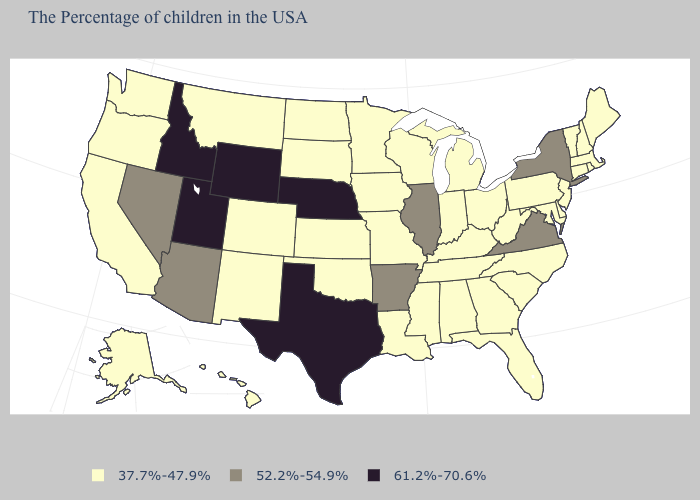Does the map have missing data?
Give a very brief answer. No. What is the lowest value in the USA?
Concise answer only. 37.7%-47.9%. Name the states that have a value in the range 61.2%-70.6%?
Concise answer only. Nebraska, Texas, Wyoming, Utah, Idaho. What is the value of Maine?
Short answer required. 37.7%-47.9%. Name the states that have a value in the range 52.2%-54.9%?
Concise answer only. New York, Virginia, Illinois, Arkansas, Arizona, Nevada. Name the states that have a value in the range 37.7%-47.9%?
Give a very brief answer. Maine, Massachusetts, Rhode Island, New Hampshire, Vermont, Connecticut, New Jersey, Delaware, Maryland, Pennsylvania, North Carolina, South Carolina, West Virginia, Ohio, Florida, Georgia, Michigan, Kentucky, Indiana, Alabama, Tennessee, Wisconsin, Mississippi, Louisiana, Missouri, Minnesota, Iowa, Kansas, Oklahoma, South Dakota, North Dakota, Colorado, New Mexico, Montana, California, Washington, Oregon, Alaska, Hawaii. Does Idaho have the highest value in the USA?
Give a very brief answer. Yes. Does New York have the lowest value in the Northeast?
Give a very brief answer. No. Name the states that have a value in the range 52.2%-54.9%?
Concise answer only. New York, Virginia, Illinois, Arkansas, Arizona, Nevada. What is the lowest value in states that border North Carolina?
Quick response, please. 37.7%-47.9%. Does Texas have the lowest value in the USA?
Answer briefly. No. What is the value of Idaho?
Answer briefly. 61.2%-70.6%. Name the states that have a value in the range 61.2%-70.6%?
Write a very short answer. Nebraska, Texas, Wyoming, Utah, Idaho. 